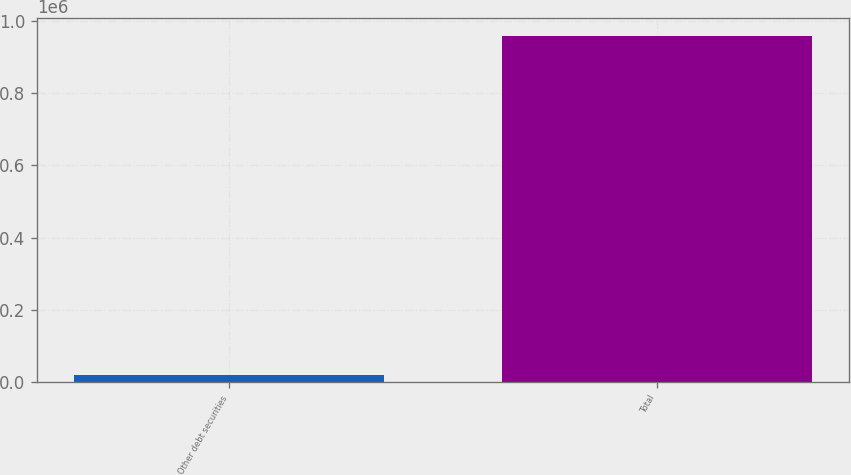Convert chart to OTSL. <chart><loc_0><loc_0><loc_500><loc_500><bar_chart><fcel>Other debt securities<fcel>Total<nl><fcel>21020<fcel>958032<nl></chart> 